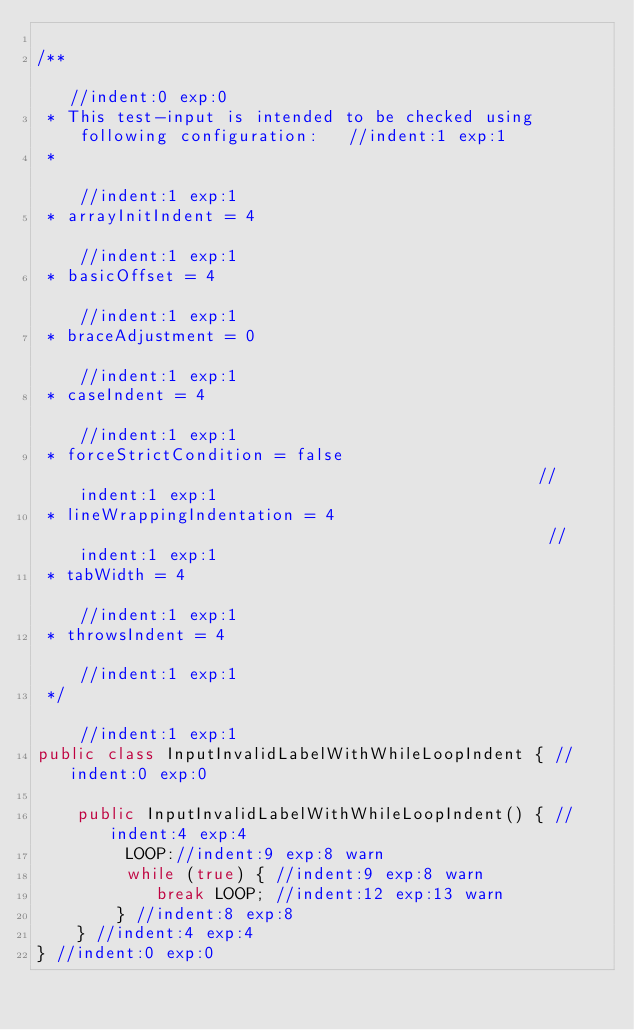<code> <loc_0><loc_0><loc_500><loc_500><_Java_>
/**                                                                           //indent:0 exp:0
 * This test-input is intended to be checked using following configuration:   //indent:1 exp:1
 *                                                                            //indent:1 exp:1
 * arrayInitIndent = 4                                                        //indent:1 exp:1
 * basicOffset = 4                                                            //indent:1 exp:1
 * braceAdjustment = 0                                                        //indent:1 exp:1
 * caseIndent = 4                                                             //indent:1 exp:1
 * forceStrictCondition = false                                               //indent:1 exp:1
 * lineWrappingIndentation = 4                                                //indent:1 exp:1
 * tabWidth = 4                                                               //indent:1 exp:1
 * throwsIndent = 4                                                           //indent:1 exp:1
 */                                                                           //indent:1 exp:1
public class InputInvalidLabelWithWhileLoopIndent { //indent:0 exp:0

    public InputInvalidLabelWithWhileLoopIndent() { //indent:4 exp:4
         LOOP://indent:9 exp:8 warn
         while (true) { //indent:9 exp:8 warn
            break LOOP; //indent:12 exp:13 warn
        } //indent:8 exp:8
    } //indent:4 exp:4
} //indent:0 exp:0
</code> 